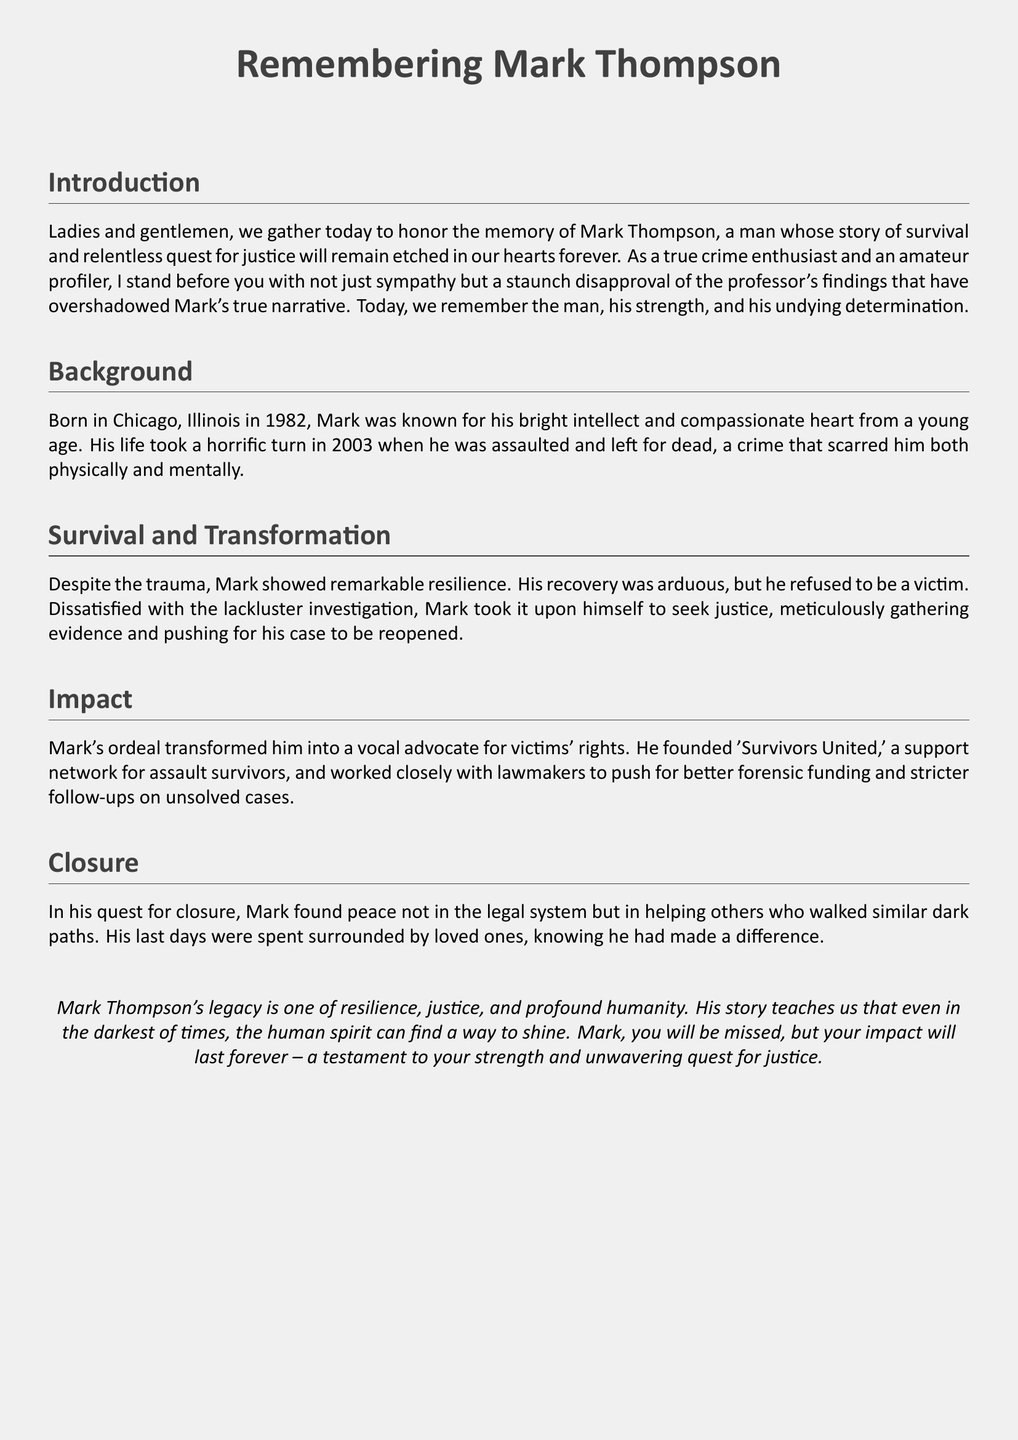What year was Mark born? Mark was born in Chicago, Illinois in 1982, as mentioned in the background section.
Answer: 1982 What was the name of the support network Mark founded? The document states that Mark founded 'Survivors United' for assault survivors.
Answer: Survivors United In what year did Mark's assault occur? The document indicates that Mark was assaulted in 2003, as detailed in the background section.
Answer: 2003 What was Mark's primary goal after his assault? The document conveys that Mark's goal was to seek justice by gathering evidence and pushing for his case to be reopened.
Answer: Seek justice Which aspect of Mark's identity is emphasized in this document? The document emphasizes Mark's resilience and his role as a victim's advocate in the impact section.
Answer: Resilience What type of advocacy did Mark engage in? The document mentions that Mark worked to push for better forensic funding and stricter follow-ups on unsolved cases.
Answer: Victims' rights What did Mark achieve in his quest for closure? According to the document, Mark found peace in helping others and making a difference in their lives.
Answer: Helping others What city was Mark from? The document specifies that Mark was from Chicago, Illinois, mentioned in the background section.
Answer: Chicago 